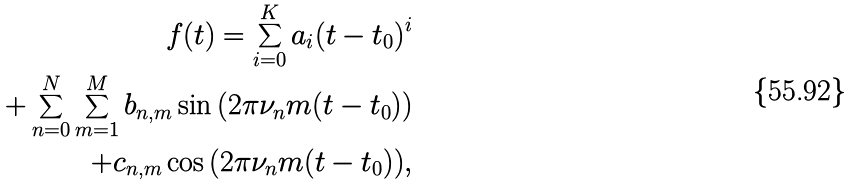<formula> <loc_0><loc_0><loc_500><loc_500>f ( t ) = \sum _ { i = 0 } ^ { K } a _ { i } ( t - t _ { 0 } ) ^ { i } \\ + \sum _ { n = 0 } ^ { N } \sum _ { m = 1 } ^ { M } b _ { n , m } \sin { ( 2 \pi \nu _ { n } m ( t - t _ { 0 } ) ) } \\ + c _ { n , m } \cos { ( 2 \pi \nu _ { n } m ( t - t _ { 0 } ) ) } ,</formula> 